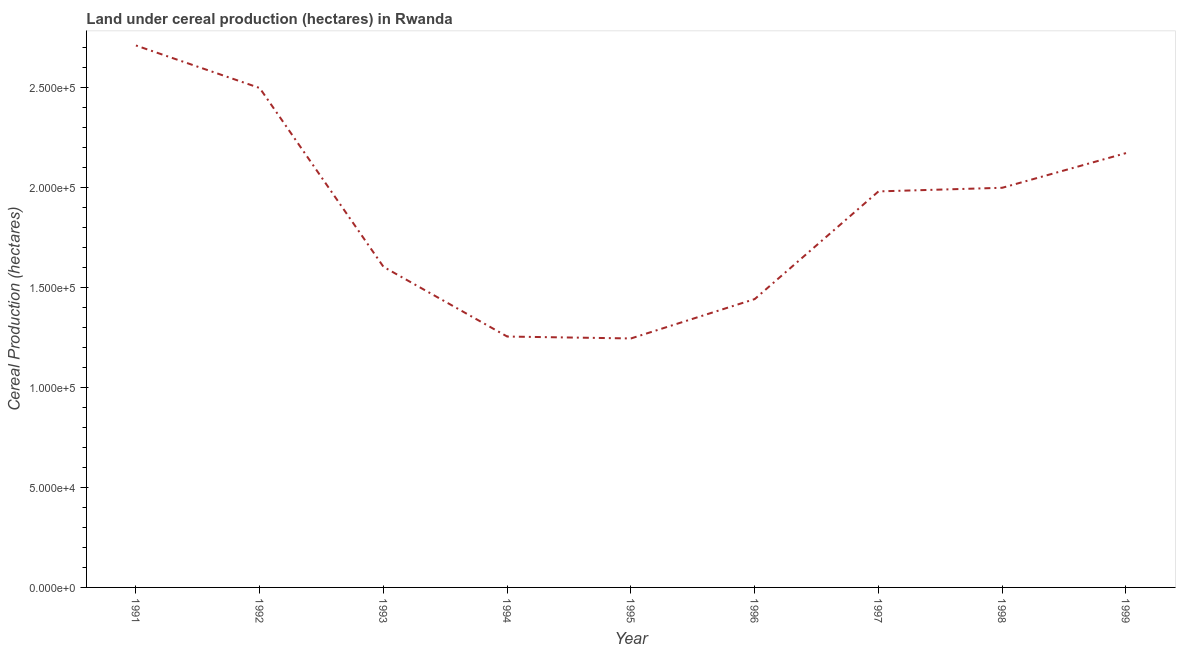What is the land under cereal production in 1991?
Ensure brevity in your answer.  2.71e+05. Across all years, what is the maximum land under cereal production?
Your response must be concise. 2.71e+05. Across all years, what is the minimum land under cereal production?
Your answer should be compact. 1.24e+05. In which year was the land under cereal production minimum?
Offer a very short reply. 1995. What is the sum of the land under cereal production?
Your response must be concise. 1.69e+06. What is the difference between the land under cereal production in 1995 and 1998?
Your answer should be very brief. -7.53e+04. What is the average land under cereal production per year?
Your response must be concise. 1.88e+05. What is the median land under cereal production?
Provide a succinct answer. 1.98e+05. Do a majority of the years between 1995 and 1997 (inclusive) have land under cereal production greater than 90000 hectares?
Offer a terse response. Yes. What is the ratio of the land under cereal production in 1992 to that in 1994?
Offer a terse response. 1.99. Is the land under cereal production in 1994 less than that in 1997?
Offer a terse response. Yes. What is the difference between the highest and the second highest land under cereal production?
Your answer should be very brief. 2.13e+04. What is the difference between the highest and the lowest land under cereal production?
Offer a terse response. 1.46e+05. How many lines are there?
Your answer should be compact. 1. What is the difference between two consecutive major ticks on the Y-axis?
Offer a terse response. 5.00e+04. Are the values on the major ticks of Y-axis written in scientific E-notation?
Make the answer very short. Yes. Does the graph contain grids?
Keep it short and to the point. No. What is the title of the graph?
Your answer should be compact. Land under cereal production (hectares) in Rwanda. What is the label or title of the Y-axis?
Make the answer very short. Cereal Production (hectares). What is the Cereal Production (hectares) of 1991?
Make the answer very short. 2.71e+05. What is the Cereal Production (hectares) in 1992?
Give a very brief answer. 2.50e+05. What is the Cereal Production (hectares) in 1993?
Your answer should be very brief. 1.60e+05. What is the Cereal Production (hectares) of 1994?
Offer a terse response. 1.25e+05. What is the Cereal Production (hectares) of 1995?
Your answer should be very brief. 1.24e+05. What is the Cereal Production (hectares) in 1996?
Give a very brief answer. 1.44e+05. What is the Cereal Production (hectares) in 1997?
Your response must be concise. 1.98e+05. What is the Cereal Production (hectares) of 1998?
Your answer should be very brief. 2.00e+05. What is the Cereal Production (hectares) of 1999?
Offer a terse response. 2.17e+05. What is the difference between the Cereal Production (hectares) in 1991 and 1992?
Give a very brief answer. 2.13e+04. What is the difference between the Cereal Production (hectares) in 1991 and 1993?
Keep it short and to the point. 1.11e+05. What is the difference between the Cereal Production (hectares) in 1991 and 1994?
Your response must be concise. 1.45e+05. What is the difference between the Cereal Production (hectares) in 1991 and 1995?
Your response must be concise. 1.46e+05. What is the difference between the Cereal Production (hectares) in 1991 and 1996?
Give a very brief answer. 1.27e+05. What is the difference between the Cereal Production (hectares) in 1991 and 1997?
Make the answer very short. 7.29e+04. What is the difference between the Cereal Production (hectares) in 1991 and 1998?
Provide a succinct answer. 7.11e+04. What is the difference between the Cereal Production (hectares) in 1991 and 1999?
Make the answer very short. 5.38e+04. What is the difference between the Cereal Production (hectares) in 1992 and 1993?
Ensure brevity in your answer.  8.93e+04. What is the difference between the Cereal Production (hectares) in 1992 and 1994?
Offer a terse response. 1.24e+05. What is the difference between the Cereal Production (hectares) in 1992 and 1995?
Give a very brief answer. 1.25e+05. What is the difference between the Cereal Production (hectares) in 1992 and 1996?
Give a very brief answer. 1.05e+05. What is the difference between the Cereal Production (hectares) in 1992 and 1997?
Provide a succinct answer. 5.17e+04. What is the difference between the Cereal Production (hectares) in 1992 and 1998?
Your response must be concise. 4.98e+04. What is the difference between the Cereal Production (hectares) in 1992 and 1999?
Keep it short and to the point. 3.25e+04. What is the difference between the Cereal Production (hectares) in 1993 and 1994?
Your answer should be compact. 3.48e+04. What is the difference between the Cereal Production (hectares) in 1993 and 1995?
Offer a very short reply. 3.58e+04. What is the difference between the Cereal Production (hectares) in 1993 and 1996?
Keep it short and to the point. 1.61e+04. What is the difference between the Cereal Production (hectares) in 1993 and 1997?
Your answer should be compact. -3.77e+04. What is the difference between the Cereal Production (hectares) in 1993 and 1998?
Offer a terse response. -3.95e+04. What is the difference between the Cereal Production (hectares) in 1993 and 1999?
Offer a very short reply. -5.68e+04. What is the difference between the Cereal Production (hectares) in 1994 and 1995?
Your answer should be very brief. 954. What is the difference between the Cereal Production (hectares) in 1994 and 1996?
Provide a short and direct response. -1.87e+04. What is the difference between the Cereal Production (hectares) in 1994 and 1997?
Provide a succinct answer. -7.25e+04. What is the difference between the Cereal Production (hectares) in 1994 and 1998?
Ensure brevity in your answer.  -7.43e+04. What is the difference between the Cereal Production (hectares) in 1994 and 1999?
Provide a succinct answer. -9.17e+04. What is the difference between the Cereal Production (hectares) in 1995 and 1996?
Provide a short and direct response. -1.97e+04. What is the difference between the Cereal Production (hectares) in 1995 and 1997?
Offer a very short reply. -7.35e+04. What is the difference between the Cereal Production (hectares) in 1995 and 1998?
Offer a terse response. -7.53e+04. What is the difference between the Cereal Production (hectares) in 1995 and 1999?
Offer a very short reply. -9.26e+04. What is the difference between the Cereal Production (hectares) in 1996 and 1997?
Make the answer very short. -5.38e+04. What is the difference between the Cereal Production (hectares) in 1996 and 1998?
Give a very brief answer. -5.56e+04. What is the difference between the Cereal Production (hectares) in 1996 and 1999?
Offer a terse response. -7.29e+04. What is the difference between the Cereal Production (hectares) in 1997 and 1998?
Offer a terse response. -1812. What is the difference between the Cereal Production (hectares) in 1997 and 1999?
Provide a succinct answer. -1.91e+04. What is the difference between the Cereal Production (hectares) in 1998 and 1999?
Offer a very short reply. -1.73e+04. What is the ratio of the Cereal Production (hectares) in 1991 to that in 1992?
Provide a succinct answer. 1.08. What is the ratio of the Cereal Production (hectares) in 1991 to that in 1993?
Provide a succinct answer. 1.69. What is the ratio of the Cereal Production (hectares) in 1991 to that in 1994?
Make the answer very short. 2.16. What is the ratio of the Cereal Production (hectares) in 1991 to that in 1995?
Your answer should be very brief. 2.18. What is the ratio of the Cereal Production (hectares) in 1991 to that in 1996?
Your response must be concise. 1.88. What is the ratio of the Cereal Production (hectares) in 1991 to that in 1997?
Offer a very short reply. 1.37. What is the ratio of the Cereal Production (hectares) in 1991 to that in 1998?
Ensure brevity in your answer.  1.36. What is the ratio of the Cereal Production (hectares) in 1991 to that in 1999?
Give a very brief answer. 1.25. What is the ratio of the Cereal Production (hectares) in 1992 to that in 1993?
Your answer should be very brief. 1.56. What is the ratio of the Cereal Production (hectares) in 1992 to that in 1994?
Provide a succinct answer. 1.99. What is the ratio of the Cereal Production (hectares) in 1992 to that in 1995?
Provide a succinct answer. 2.01. What is the ratio of the Cereal Production (hectares) in 1992 to that in 1996?
Your answer should be compact. 1.73. What is the ratio of the Cereal Production (hectares) in 1992 to that in 1997?
Ensure brevity in your answer.  1.26. What is the ratio of the Cereal Production (hectares) in 1992 to that in 1998?
Provide a succinct answer. 1.25. What is the ratio of the Cereal Production (hectares) in 1992 to that in 1999?
Provide a short and direct response. 1.15. What is the ratio of the Cereal Production (hectares) in 1993 to that in 1994?
Keep it short and to the point. 1.28. What is the ratio of the Cereal Production (hectares) in 1993 to that in 1995?
Give a very brief answer. 1.29. What is the ratio of the Cereal Production (hectares) in 1993 to that in 1996?
Provide a succinct answer. 1.11. What is the ratio of the Cereal Production (hectares) in 1993 to that in 1997?
Offer a terse response. 0.81. What is the ratio of the Cereal Production (hectares) in 1993 to that in 1998?
Offer a terse response. 0.8. What is the ratio of the Cereal Production (hectares) in 1993 to that in 1999?
Give a very brief answer. 0.74. What is the ratio of the Cereal Production (hectares) in 1994 to that in 1995?
Give a very brief answer. 1.01. What is the ratio of the Cereal Production (hectares) in 1994 to that in 1996?
Make the answer very short. 0.87. What is the ratio of the Cereal Production (hectares) in 1994 to that in 1997?
Ensure brevity in your answer.  0.63. What is the ratio of the Cereal Production (hectares) in 1994 to that in 1998?
Your response must be concise. 0.63. What is the ratio of the Cereal Production (hectares) in 1994 to that in 1999?
Offer a terse response. 0.58. What is the ratio of the Cereal Production (hectares) in 1995 to that in 1996?
Give a very brief answer. 0.86. What is the ratio of the Cereal Production (hectares) in 1995 to that in 1997?
Make the answer very short. 0.63. What is the ratio of the Cereal Production (hectares) in 1995 to that in 1998?
Offer a terse response. 0.62. What is the ratio of the Cereal Production (hectares) in 1995 to that in 1999?
Keep it short and to the point. 0.57. What is the ratio of the Cereal Production (hectares) in 1996 to that in 1997?
Keep it short and to the point. 0.73. What is the ratio of the Cereal Production (hectares) in 1996 to that in 1998?
Give a very brief answer. 0.72. What is the ratio of the Cereal Production (hectares) in 1996 to that in 1999?
Offer a terse response. 0.66. What is the ratio of the Cereal Production (hectares) in 1997 to that in 1998?
Make the answer very short. 0.99. What is the ratio of the Cereal Production (hectares) in 1997 to that in 1999?
Offer a terse response. 0.91. What is the ratio of the Cereal Production (hectares) in 1998 to that in 1999?
Provide a succinct answer. 0.92. 